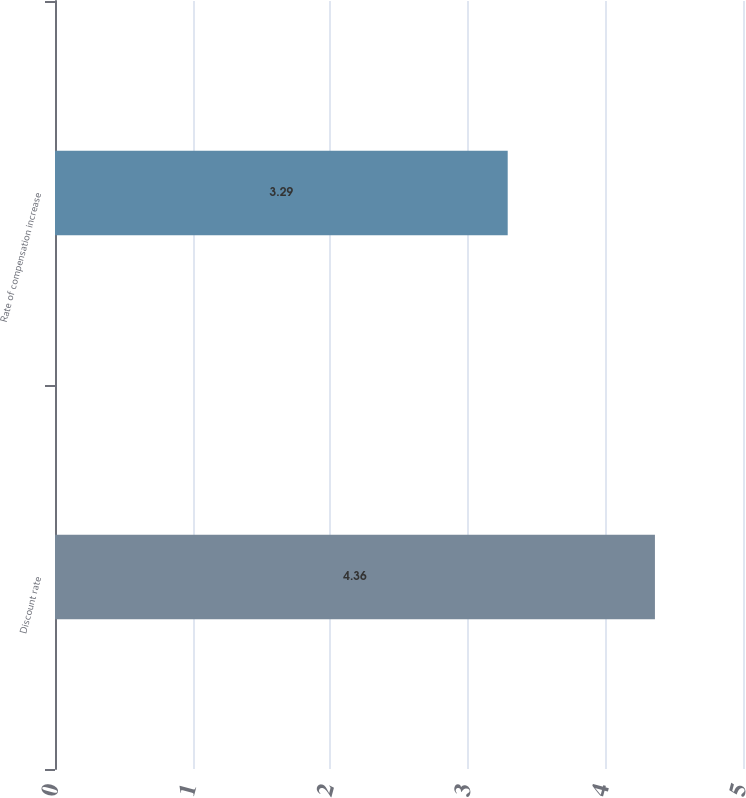Convert chart to OTSL. <chart><loc_0><loc_0><loc_500><loc_500><bar_chart><fcel>Discount rate<fcel>Rate of compensation increase<nl><fcel>4.36<fcel>3.29<nl></chart> 